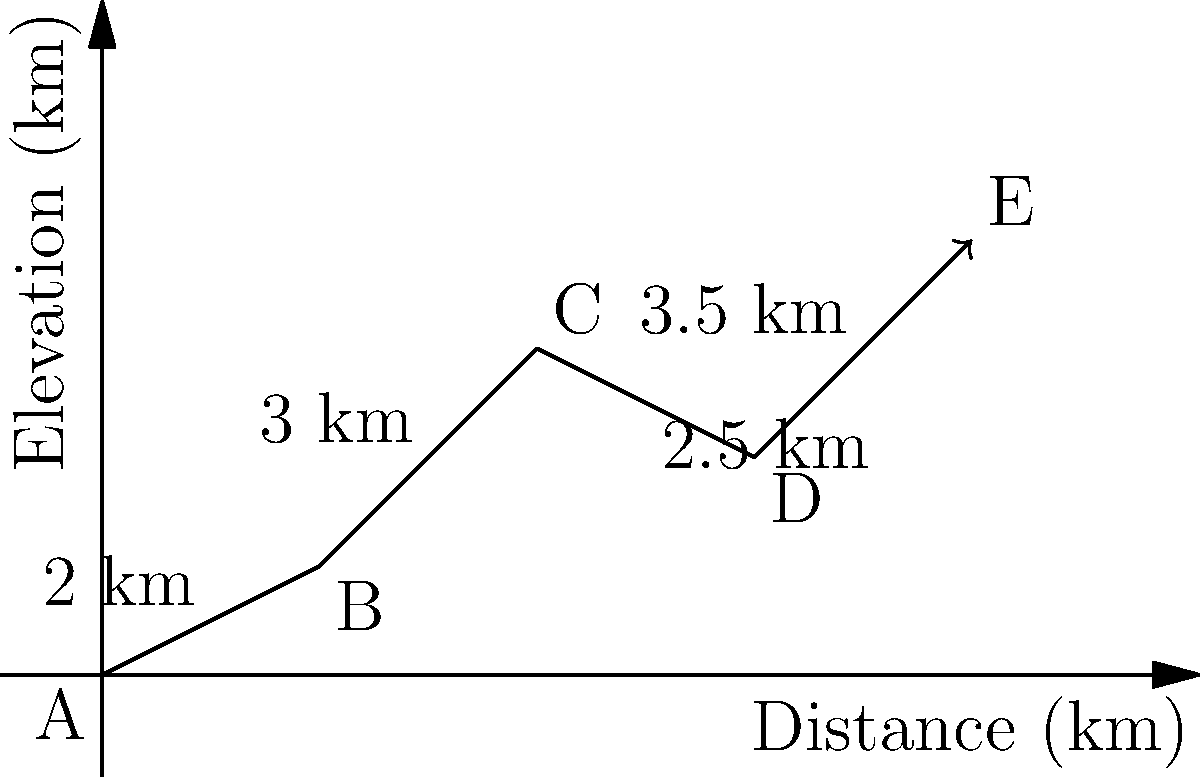A wildlife researcher tracking a tiger's movement through a forest recorded its path as shown in the diagram. The tiger traveled from point A to E, passing through points B, C, and D. If the tiger maintained an average speed of 5 km/h throughout its journey, how long did it take to travel from point A to point E? To solve this problem, we need to follow these steps:

1. Calculate the total distance traveled:
   AB = 2 km
   BC = 3 km
   CD = 2.5 km
   DE = 3.5 km
   Total distance = 2 + 3 + 2.5 + 3.5 = 11 km

2. Use the formula: Time = Distance / Speed
   Given: 
   - Total distance = 11 km
   - Average speed = 5 km/h

3. Apply the formula:
   Time = 11 km / 5 km/h = 2.2 hours

4. Convert 0.2 hours to minutes:
   0.2 hours × 60 minutes/hour = 12 minutes

Therefore, the tiger took 2 hours and 12 minutes to travel from point A to point E.
Answer: 2 hours 12 minutes 